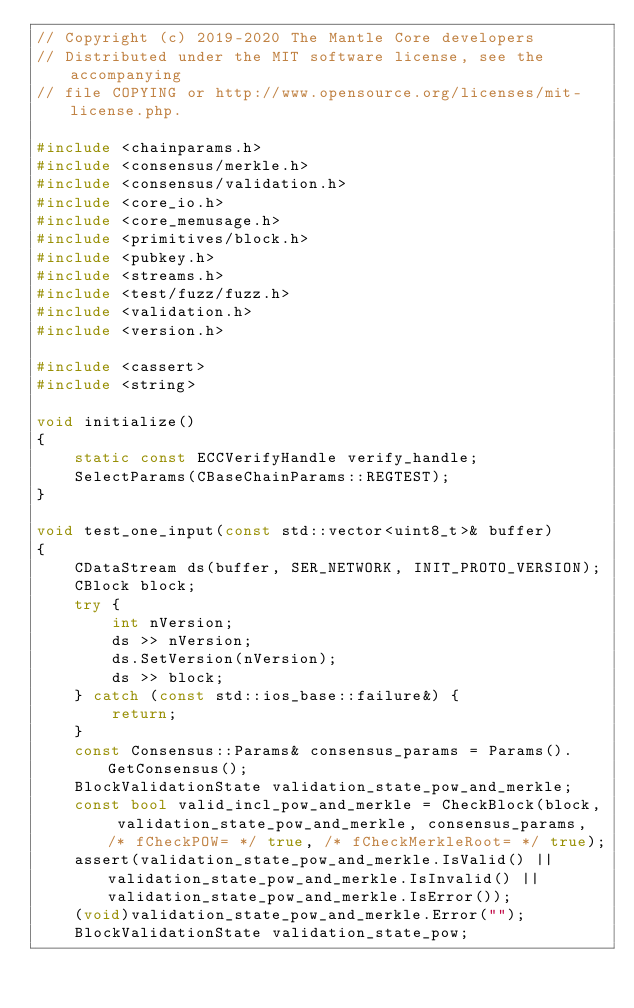Convert code to text. <code><loc_0><loc_0><loc_500><loc_500><_C++_>// Copyright (c) 2019-2020 The Mantle Core developers
// Distributed under the MIT software license, see the accompanying
// file COPYING or http://www.opensource.org/licenses/mit-license.php.

#include <chainparams.h>
#include <consensus/merkle.h>
#include <consensus/validation.h>
#include <core_io.h>
#include <core_memusage.h>
#include <primitives/block.h>
#include <pubkey.h>
#include <streams.h>
#include <test/fuzz/fuzz.h>
#include <validation.h>
#include <version.h>

#include <cassert>
#include <string>

void initialize()
{
    static const ECCVerifyHandle verify_handle;
    SelectParams(CBaseChainParams::REGTEST);
}

void test_one_input(const std::vector<uint8_t>& buffer)
{
    CDataStream ds(buffer, SER_NETWORK, INIT_PROTO_VERSION);
    CBlock block;
    try {
        int nVersion;
        ds >> nVersion;
        ds.SetVersion(nVersion);
        ds >> block;
    } catch (const std::ios_base::failure&) {
        return;
    }
    const Consensus::Params& consensus_params = Params().GetConsensus();
    BlockValidationState validation_state_pow_and_merkle;
    const bool valid_incl_pow_and_merkle = CheckBlock(block, validation_state_pow_and_merkle, consensus_params, /* fCheckPOW= */ true, /* fCheckMerkleRoot= */ true);
    assert(validation_state_pow_and_merkle.IsValid() || validation_state_pow_and_merkle.IsInvalid() || validation_state_pow_and_merkle.IsError());
    (void)validation_state_pow_and_merkle.Error("");
    BlockValidationState validation_state_pow;</code> 